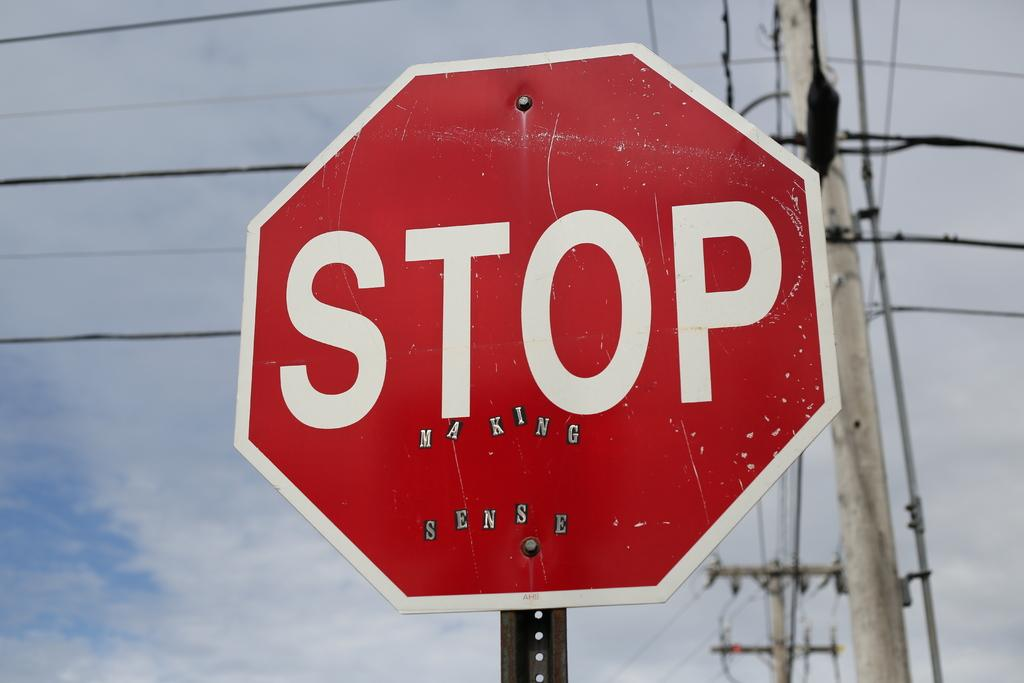<image>
Provide a brief description of the given image. Someone has added stickers to a stop sign so it says "stop making sense". 